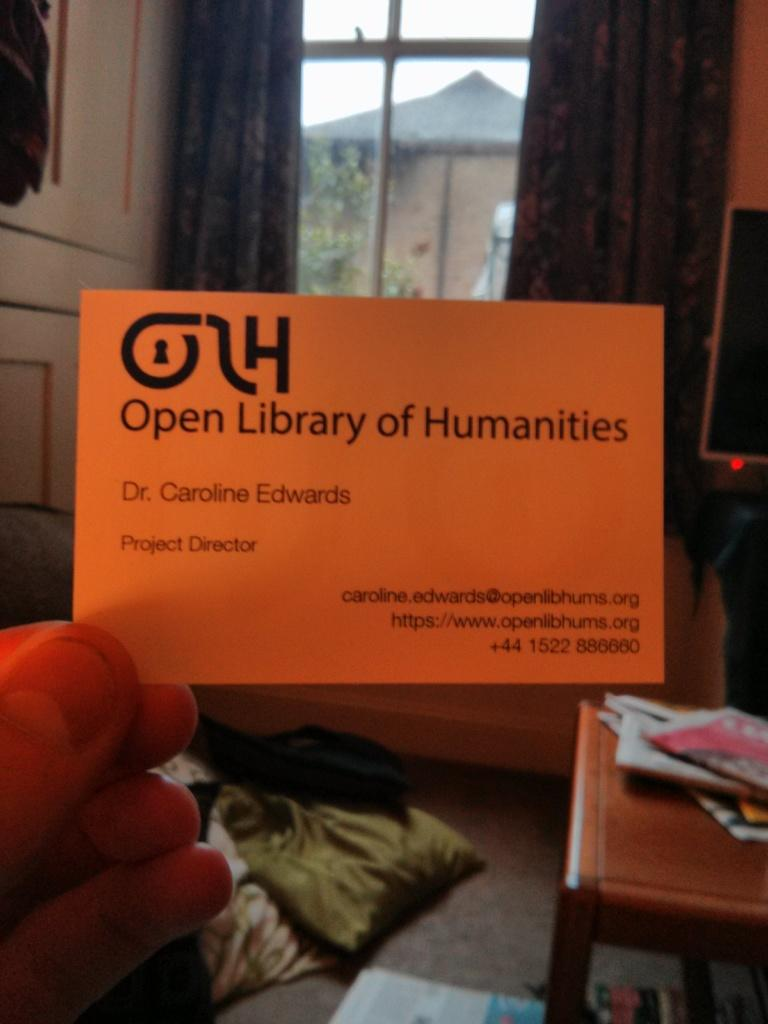Provide a one-sentence caption for the provided image. An orange card with Open Library of Humanities written on it. 